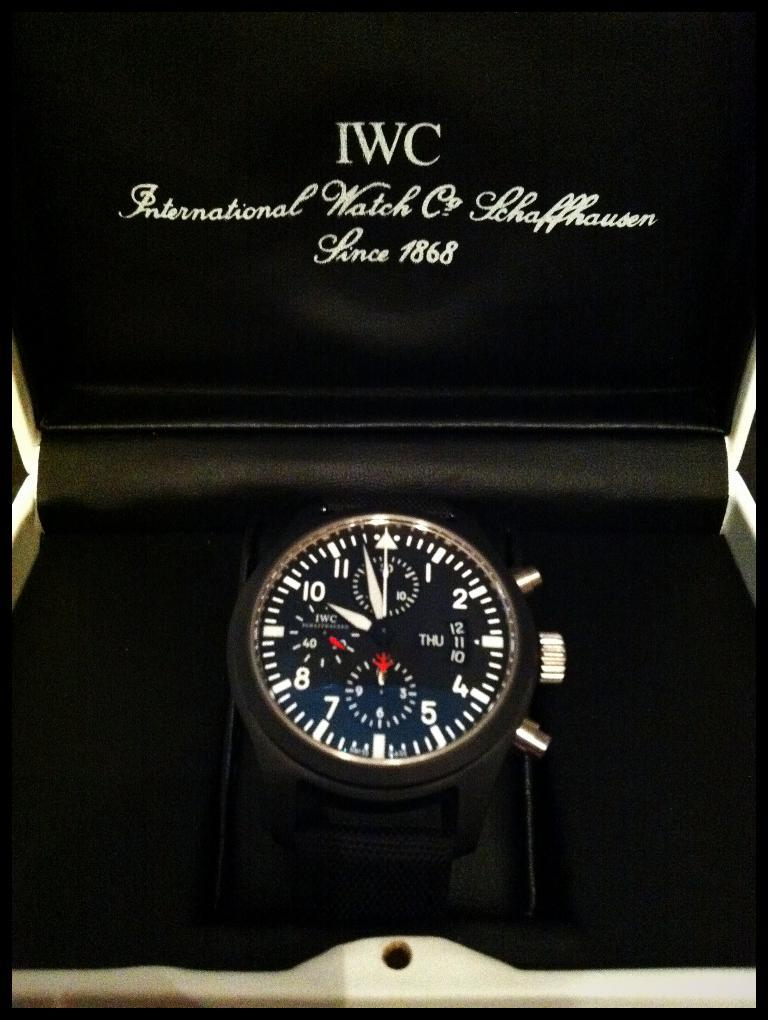<image>
Write a terse but informative summary of the picture. A box of an expensive wristwatch from the brand IWC. 